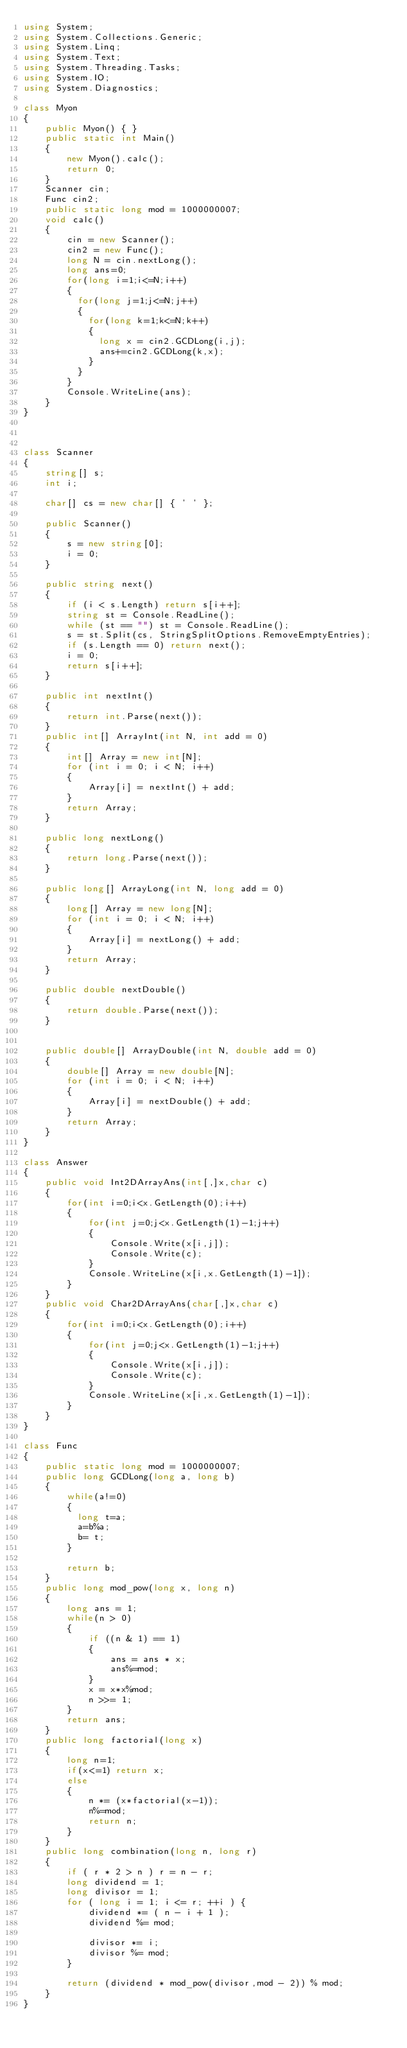<code> <loc_0><loc_0><loc_500><loc_500><_C#_>using System;
using System.Collections.Generic;
using System.Linq;
using System.Text;
using System.Threading.Tasks;
using System.IO;
using System.Diagnostics;

class Myon
{
    public Myon() { }
    public static int Main()
    {
        new Myon().calc();
        return 0;
    }
    Scanner cin;
    Func cin2;
    public static long mod = 1000000007;
    void calc()
    {
        cin = new Scanner();
        cin2 = new Func();
        long N = cin.nextLong();
        long ans=0;
        for(long i=1;i<=N;i++)
        {
          for(long j=1;j<=N;j++)
          {
            for(long k=1;k<=N;k++)
            {
              long x = cin2.GCDLong(i,j);
              ans+=cin2.GCDLong(k,x);
            }
          }
        }
        Console.WriteLine(ans);
    }
}



class Scanner
{
    string[] s;
    int i;

    char[] cs = new char[] { ' ' };

    public Scanner()
    {
        s = new string[0];
        i = 0;
    }

    public string next()
    {
        if (i < s.Length) return s[i++];
        string st = Console.ReadLine();
        while (st == "") st = Console.ReadLine();
        s = st.Split(cs, StringSplitOptions.RemoveEmptyEntries);
        if (s.Length == 0) return next();
        i = 0;
        return s[i++];
    }

    public int nextInt()
    {
        return int.Parse(next());
    }
    public int[] ArrayInt(int N, int add = 0)
    {
        int[] Array = new int[N];
        for (int i = 0; i < N; i++)
        {
            Array[i] = nextInt() + add;
        }
        return Array;
    }

    public long nextLong()
    {
        return long.Parse(next());
    }

    public long[] ArrayLong(int N, long add = 0)
    {
        long[] Array = new long[N];
        for (int i = 0; i < N; i++)
        {
            Array[i] = nextLong() + add;
        }
        return Array;
    }

    public double nextDouble()
    {
        return double.Parse(next());
    }


    public double[] ArrayDouble(int N, double add = 0)
    {
        double[] Array = new double[N];
        for (int i = 0; i < N; i++)
        {
            Array[i] = nextDouble() + add;
        }
        return Array;
    }
}

class Answer
{
    public void Int2DArrayAns(int[,]x,char c)
    {
        for(int i=0;i<x.GetLength(0);i++)
        {
            for(int j=0;j<x.GetLength(1)-1;j++)
            {
                Console.Write(x[i,j]);
                Console.Write(c);
            }
            Console.WriteLine(x[i,x.GetLength(1)-1]);
        }
    }
    public void Char2DArrayAns(char[,]x,char c)
    {
        for(int i=0;i<x.GetLength(0);i++)
        {
            for(int j=0;j<x.GetLength(1)-1;j++)
            {
                Console.Write(x[i,j]);
                Console.Write(c);
            }
            Console.WriteLine(x[i,x.GetLength(1)-1]);
        }
    }
}

class Func
{
    public static long mod = 1000000007;
    public long GCDLong(long a, long b)
    {
        while(a!=0)
        {
          long t=a;
          a=b%a;
          b= t;
        }
      
        return b;        
    }
    public long mod_pow(long x, long n)
    { 
        long ans = 1;
        while(n > 0)
        {
            if ((n & 1) == 1)
            {
                ans = ans * x;
                ans%=mod;
            }
            x = x*x%mod;
            n >>= 1;
        }
        return ans;
    }
    public long factorial(long x)
    {
        long n=1;
        if(x<=1) return x;
        else
        {
            n *= (x*factorial(x-1));
            n%=mod;
            return n;
        }
    }
    public long combination(long n, long r)
    {
        if ( r * 2 > n ) r = n - r;
		long dividend = 1;
		long divisor = 1;
		for ( long i = 1; i <= r; ++i ) {
			dividend *= ( n - i + 1 );
			dividend %= mod;
 
			divisor *= i;
			divisor %= mod;
		}
 
		return (dividend * mod_pow(divisor,mod - 2)) % mod;   
    }
}


</code> 